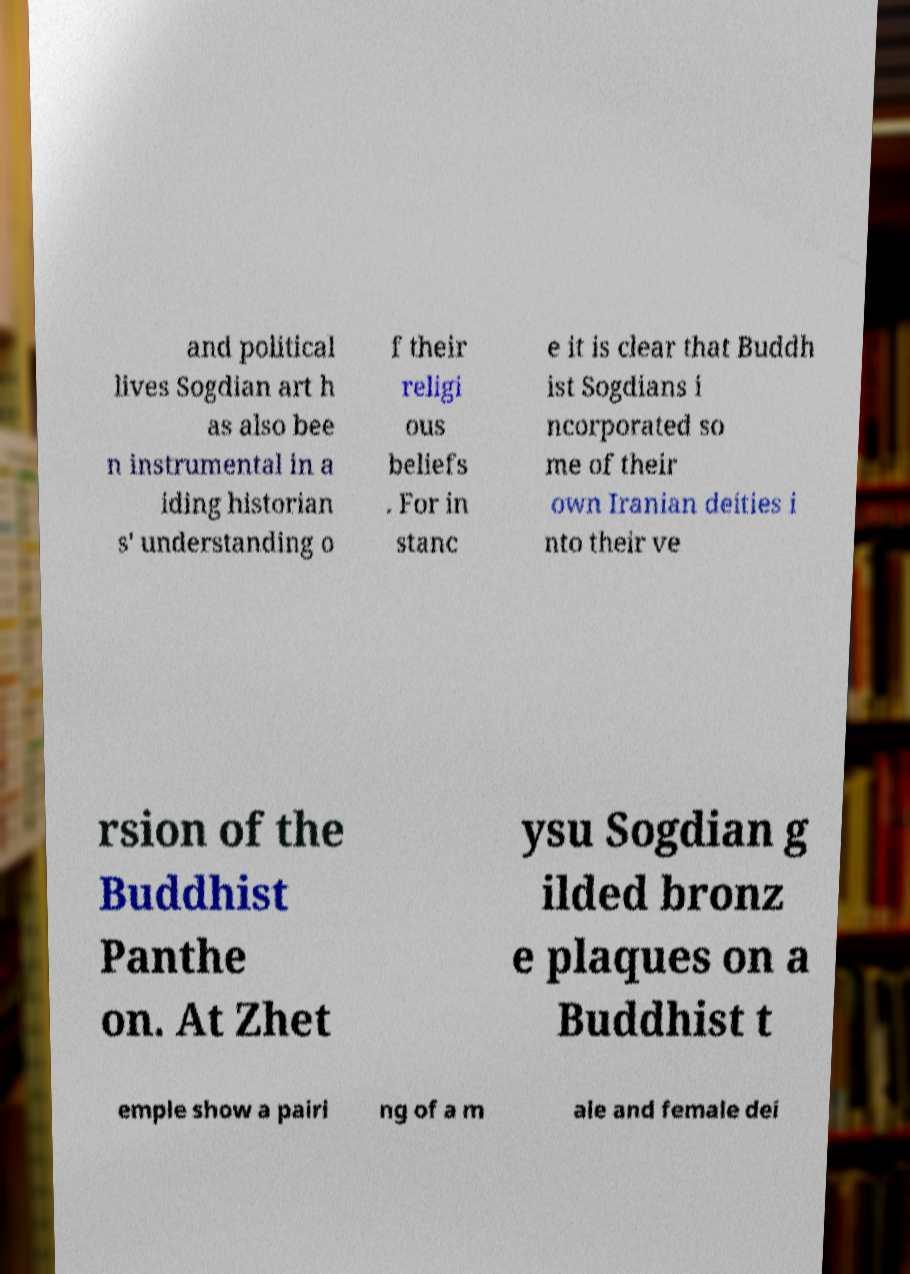There's text embedded in this image that I need extracted. Can you transcribe it verbatim? and political lives Sogdian art h as also bee n instrumental in a iding historian s' understanding o f their religi ous beliefs . For in stanc e it is clear that Buddh ist Sogdians i ncorporated so me of their own Iranian deities i nto their ve rsion of the Buddhist Panthe on. At Zhet ysu Sogdian g ilded bronz e plaques on a Buddhist t emple show a pairi ng of a m ale and female dei 